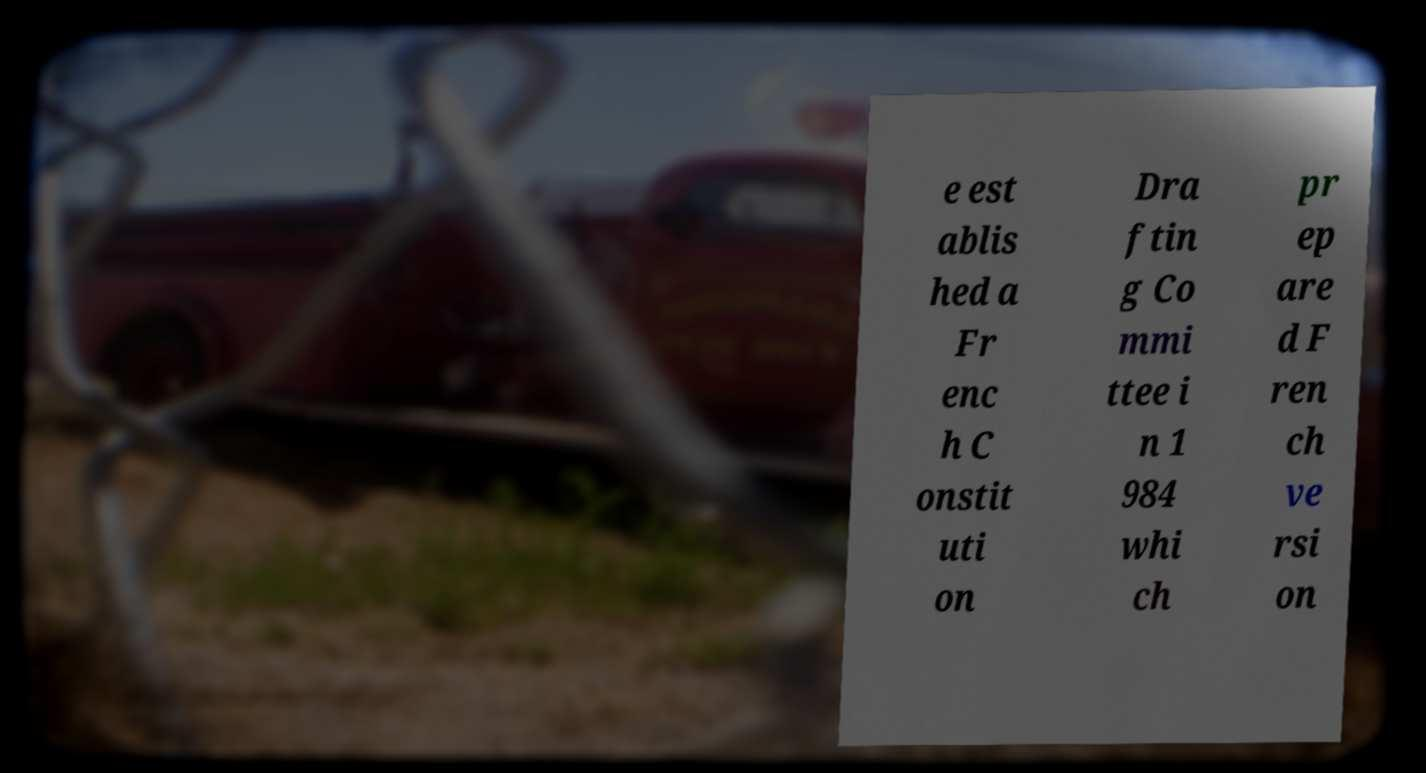There's text embedded in this image that I need extracted. Can you transcribe it verbatim? e est ablis hed a Fr enc h C onstit uti on Dra ftin g Co mmi ttee i n 1 984 whi ch pr ep are d F ren ch ve rsi on 